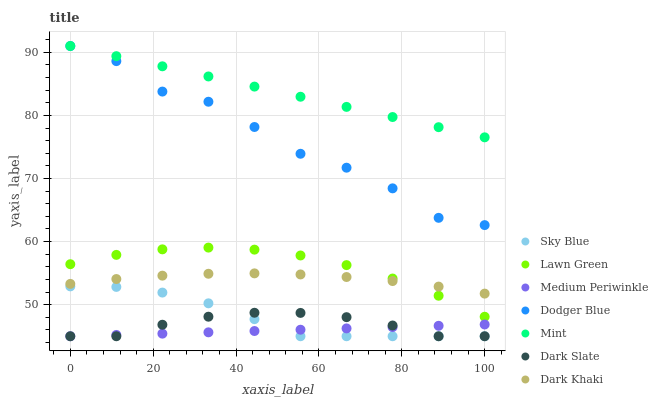Does Medium Periwinkle have the minimum area under the curve?
Answer yes or no. Yes. Does Mint have the maximum area under the curve?
Answer yes or no. Yes. Does Dark Khaki have the minimum area under the curve?
Answer yes or no. No. Does Dark Khaki have the maximum area under the curve?
Answer yes or no. No. Is Medium Periwinkle the smoothest?
Answer yes or no. Yes. Is Dodger Blue the roughest?
Answer yes or no. Yes. Is Dark Khaki the smoothest?
Answer yes or no. No. Is Dark Khaki the roughest?
Answer yes or no. No. Does Medium Periwinkle have the lowest value?
Answer yes or no. Yes. Does Dark Khaki have the lowest value?
Answer yes or no. No. Does Mint have the highest value?
Answer yes or no. Yes. Does Dark Khaki have the highest value?
Answer yes or no. No. Is Medium Periwinkle less than Dodger Blue?
Answer yes or no. Yes. Is Dodger Blue greater than Medium Periwinkle?
Answer yes or no. Yes. Does Medium Periwinkle intersect Sky Blue?
Answer yes or no. Yes. Is Medium Periwinkle less than Sky Blue?
Answer yes or no. No. Is Medium Periwinkle greater than Sky Blue?
Answer yes or no. No. Does Medium Periwinkle intersect Dodger Blue?
Answer yes or no. No. 